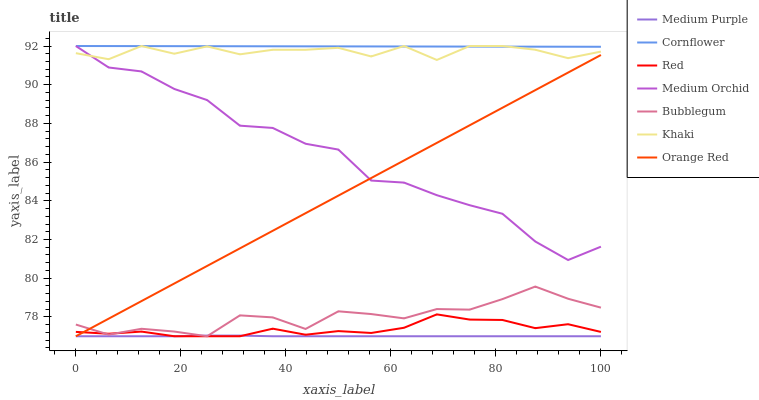Does Medium Purple have the minimum area under the curve?
Answer yes or no. Yes. Does Cornflower have the maximum area under the curve?
Answer yes or no. Yes. Does Khaki have the minimum area under the curve?
Answer yes or no. No. Does Khaki have the maximum area under the curve?
Answer yes or no. No. Is Orange Red the smoothest?
Answer yes or no. Yes. Is Medium Orchid the roughest?
Answer yes or no. Yes. Is Khaki the smoothest?
Answer yes or no. No. Is Khaki the roughest?
Answer yes or no. No. Does Khaki have the lowest value?
Answer yes or no. No. Does Bubblegum have the highest value?
Answer yes or no. No. Is Bubblegum less than Cornflower?
Answer yes or no. Yes. Is Cornflower greater than Red?
Answer yes or no. Yes. Does Bubblegum intersect Cornflower?
Answer yes or no. No. 